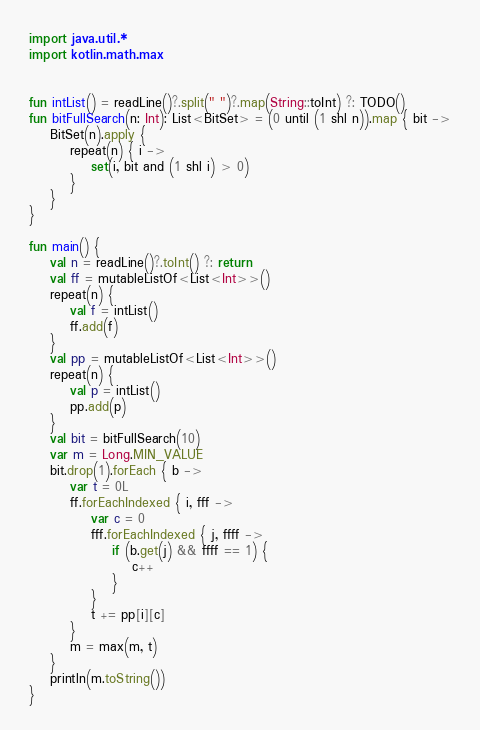Convert code to text. <code><loc_0><loc_0><loc_500><loc_500><_Kotlin_>import java.util.*
import kotlin.math.max


fun intList() = readLine()?.split(" ")?.map(String::toInt) ?: TODO()
fun bitFullSearch(n: Int): List<BitSet> = (0 until (1 shl n)).map { bit ->
    BitSet(n).apply {
        repeat(n) { i ->
            set(i, bit and (1 shl i) > 0)
        }
    }
}

fun main() {
    val n = readLine()?.toInt() ?: return
    val ff = mutableListOf<List<Int>>()
    repeat(n) {
        val f = intList()
        ff.add(f)
    }
    val pp = mutableListOf<List<Int>>()
    repeat(n) {
        val p = intList()
        pp.add(p)
    }
    val bit = bitFullSearch(10)
    var m = Long.MIN_VALUE
    bit.drop(1).forEach { b ->
        var t = 0L
        ff.forEachIndexed { i, fff ->
            var c = 0
            fff.forEachIndexed { j, ffff ->
                if (b.get(j) && ffff == 1) {
                    c++
                }
            }
            t += pp[i][c]
        }
        m = max(m, t)
    }
    println(m.toString())
}</code> 